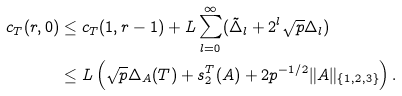<formula> <loc_0><loc_0><loc_500><loc_500>c _ { T } ( r , 0 ) & \leq c _ { T } ( 1 , r - 1 ) + L \sum _ { l = 0 } ^ { \infty } ( \tilde { \Delta } _ { l } + 2 ^ { l } \sqrt { p } \Delta _ { l } ) \\ & \leq L \left ( \sqrt { p } \Delta _ { A } ( T ) + s _ { 2 } ^ { T } ( A ) + 2 p ^ { - 1 / 2 } \| A \| _ { \{ 1 , 2 , 3 \} } \right ) .</formula> 